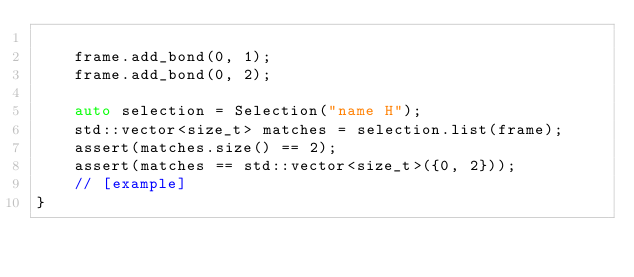Convert code to text. <code><loc_0><loc_0><loc_500><loc_500><_C++_>
    frame.add_bond(0, 1);
    frame.add_bond(0, 2);

    auto selection = Selection("name H");
    std::vector<size_t> matches = selection.list(frame);
    assert(matches.size() == 2);
    assert(matches == std::vector<size_t>({0, 2}));
    // [example]
}
</code> 